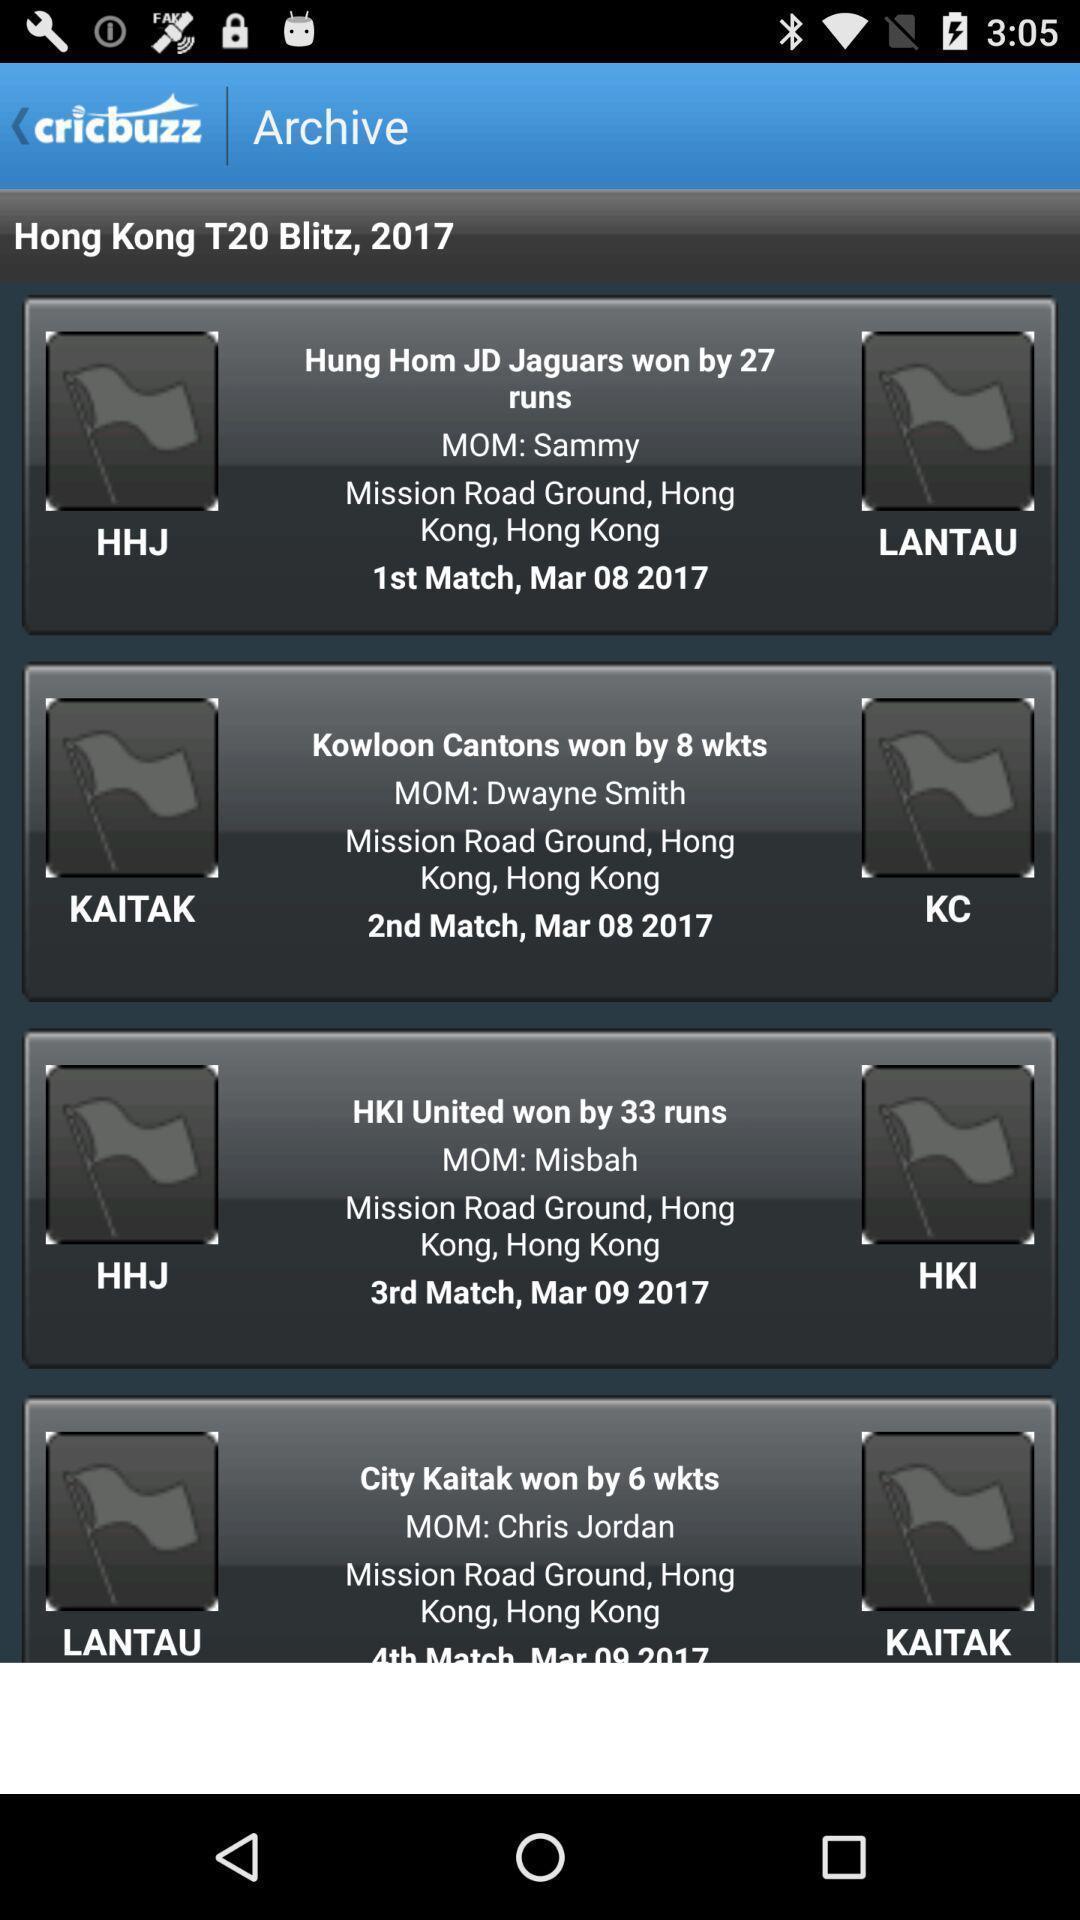What can you discern from this picture? Screen shows archive page in sports application. 